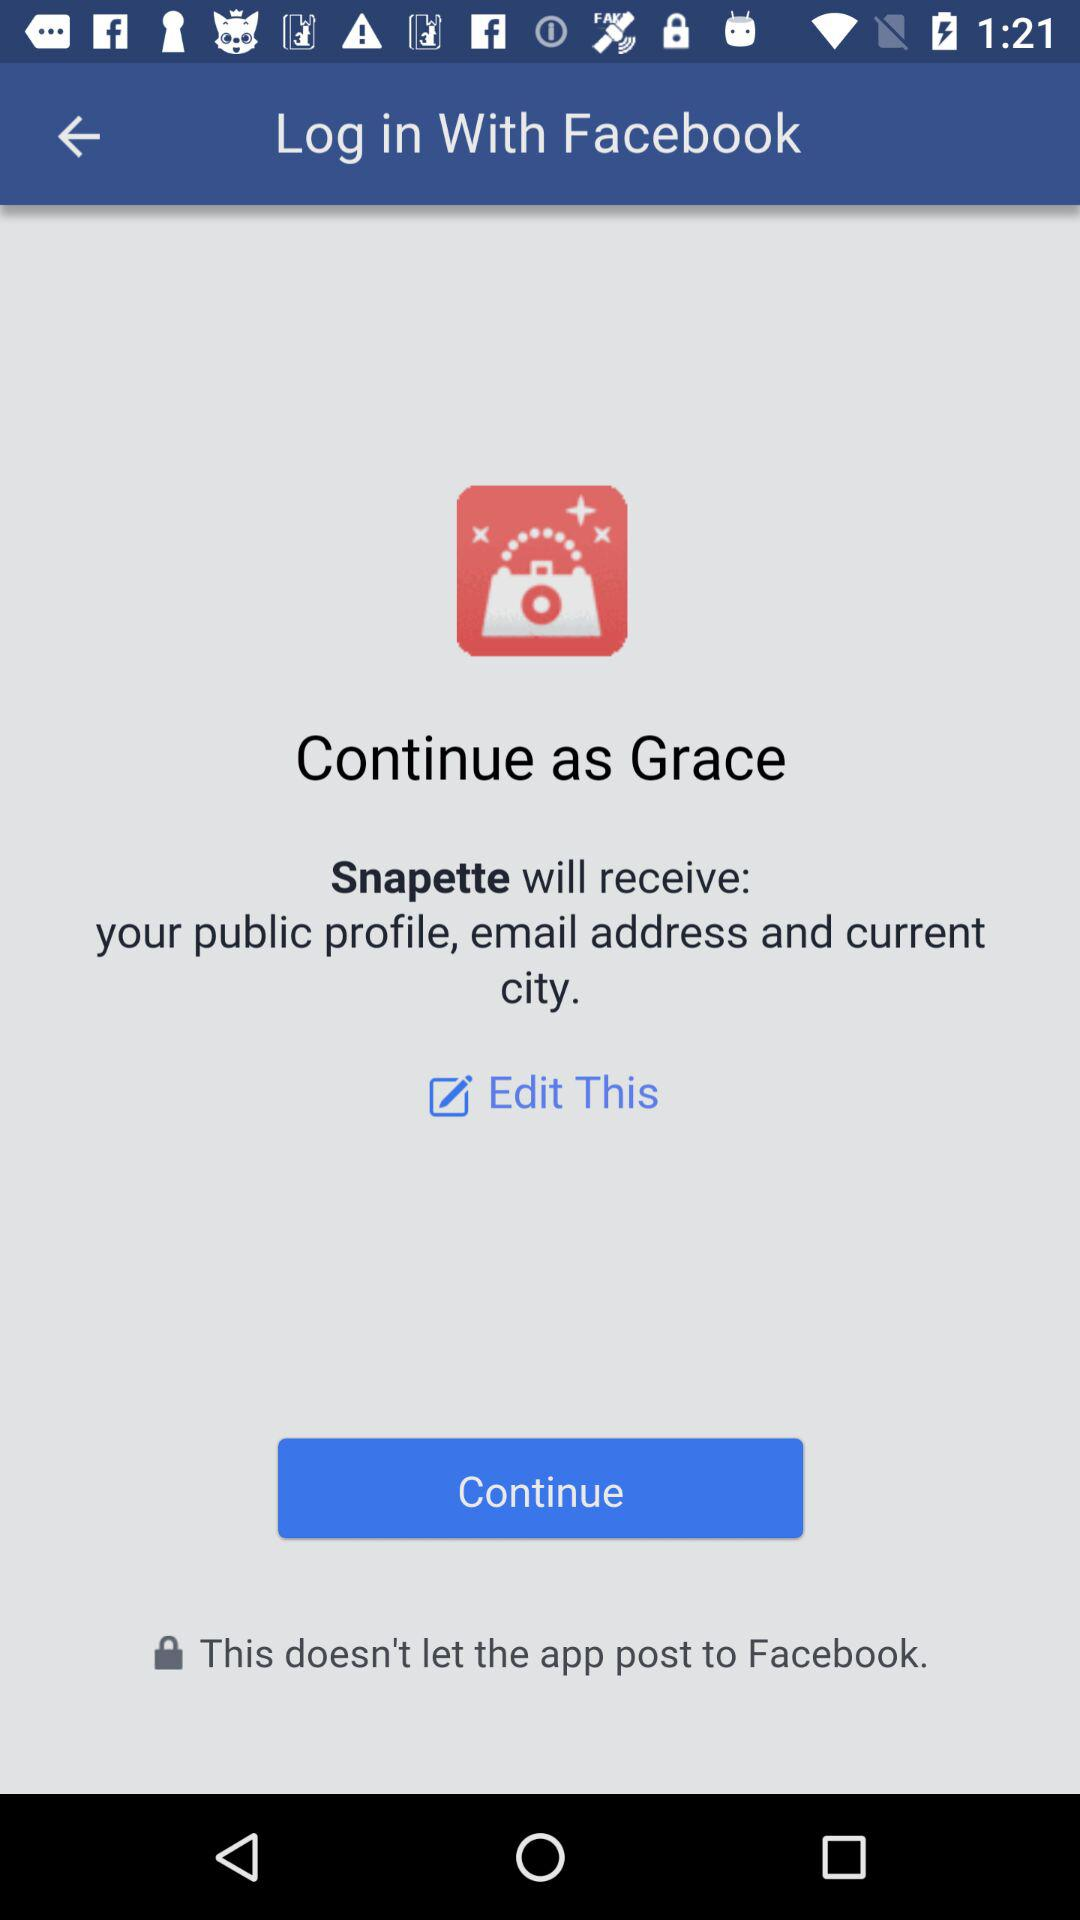What is the name of the user? The name of the user is "Grace". 